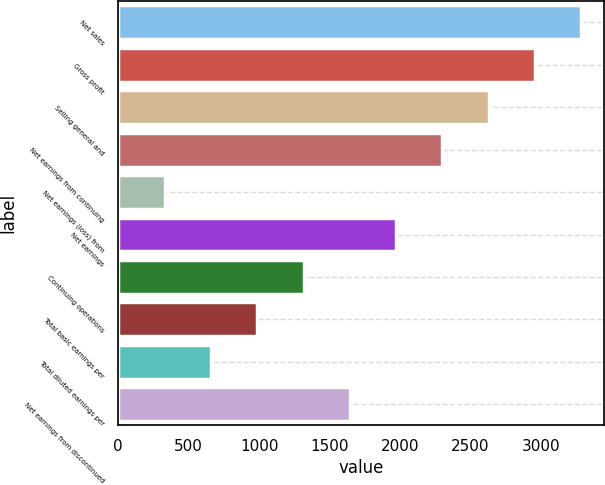<chart> <loc_0><loc_0><loc_500><loc_500><bar_chart><fcel>Net sales<fcel>Gross profit<fcel>Selling general and<fcel>Net earnings from continuing<fcel>Net earnings (loss) from<fcel>Net earnings<fcel>Continuing operations<fcel>Total basic earnings per<fcel>Total diluted earnings per<fcel>Net earnings from discontinued<nl><fcel>3285.3<fcel>2956.91<fcel>2628.54<fcel>2300.17<fcel>329.95<fcel>1971.8<fcel>1315.06<fcel>986.69<fcel>658.32<fcel>1643.43<nl></chart> 